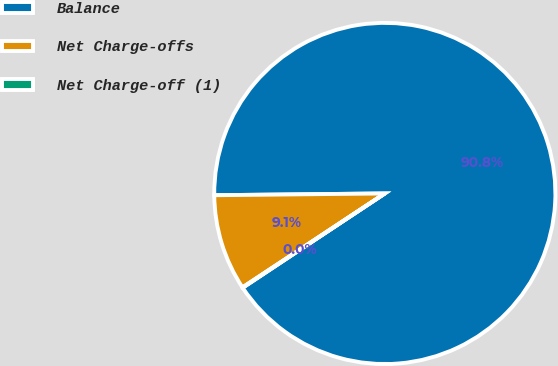<chart> <loc_0><loc_0><loc_500><loc_500><pie_chart><fcel>Balance<fcel>Net Charge-offs<fcel>Net Charge-off (1)<nl><fcel>90.85%<fcel>9.12%<fcel>0.04%<nl></chart> 